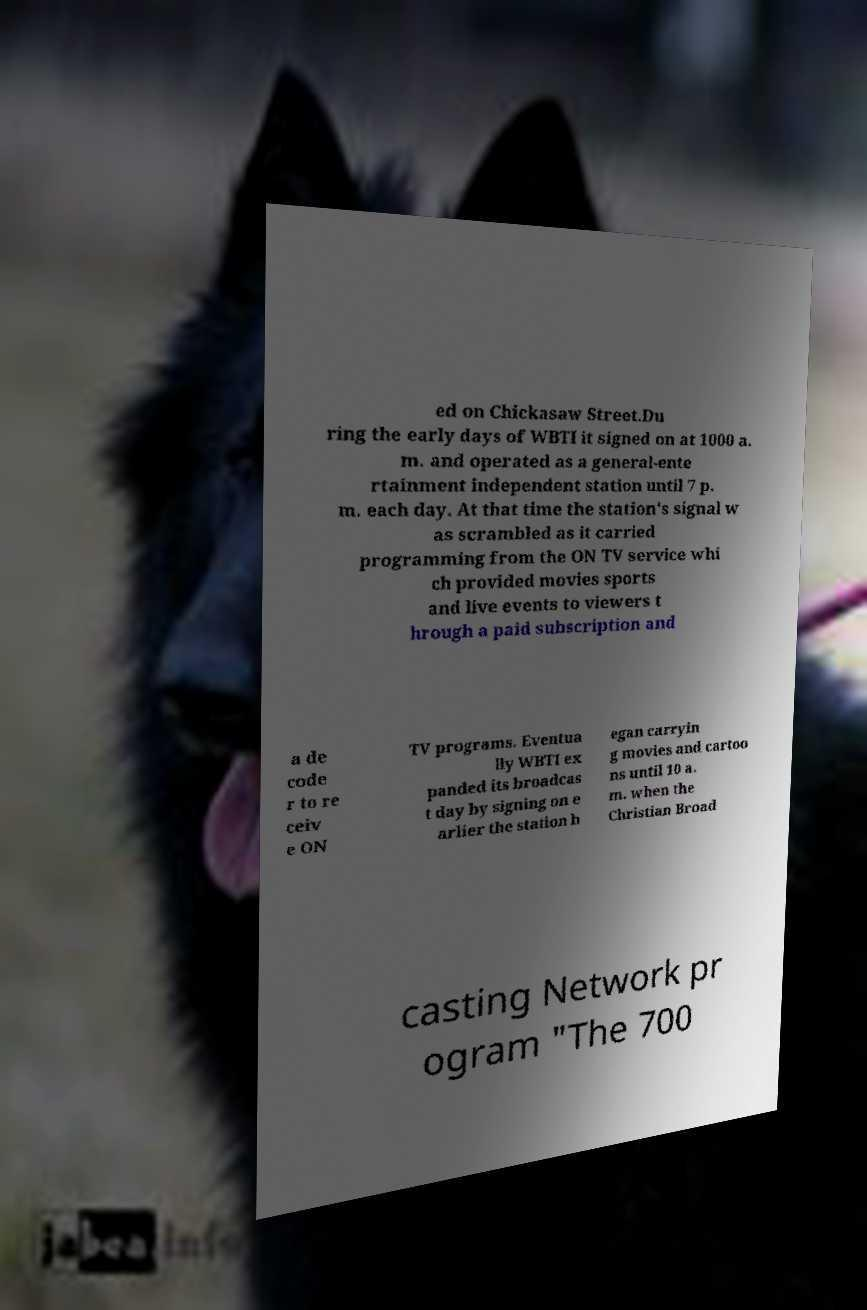I need the written content from this picture converted into text. Can you do that? ed on Chickasaw Street.Du ring the early days of WBTI it signed on at 1000 a. m. and operated as a general-ente rtainment independent station until 7 p. m. each day. At that time the station's signal w as scrambled as it carried programming from the ON TV service whi ch provided movies sports and live events to viewers t hrough a paid subscription and a de code r to re ceiv e ON TV programs. Eventua lly WBTI ex panded its broadcas t day by signing on e arlier the station b egan carryin g movies and cartoo ns until 10 a. m. when the Christian Broad casting Network pr ogram "The 700 